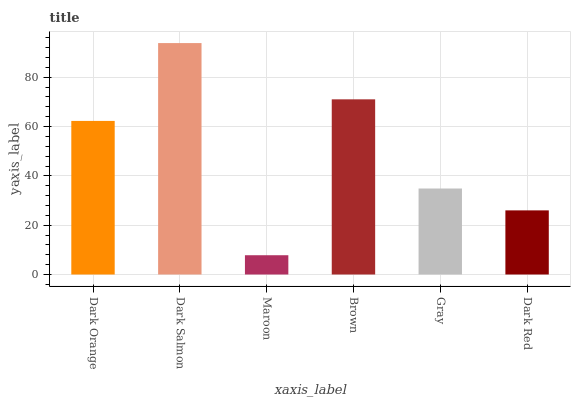Is Maroon the minimum?
Answer yes or no. Yes. Is Dark Salmon the maximum?
Answer yes or no. Yes. Is Dark Salmon the minimum?
Answer yes or no. No. Is Maroon the maximum?
Answer yes or no. No. Is Dark Salmon greater than Maroon?
Answer yes or no. Yes. Is Maroon less than Dark Salmon?
Answer yes or no. Yes. Is Maroon greater than Dark Salmon?
Answer yes or no. No. Is Dark Salmon less than Maroon?
Answer yes or no. No. Is Dark Orange the high median?
Answer yes or no. Yes. Is Gray the low median?
Answer yes or no. Yes. Is Maroon the high median?
Answer yes or no. No. Is Maroon the low median?
Answer yes or no. No. 